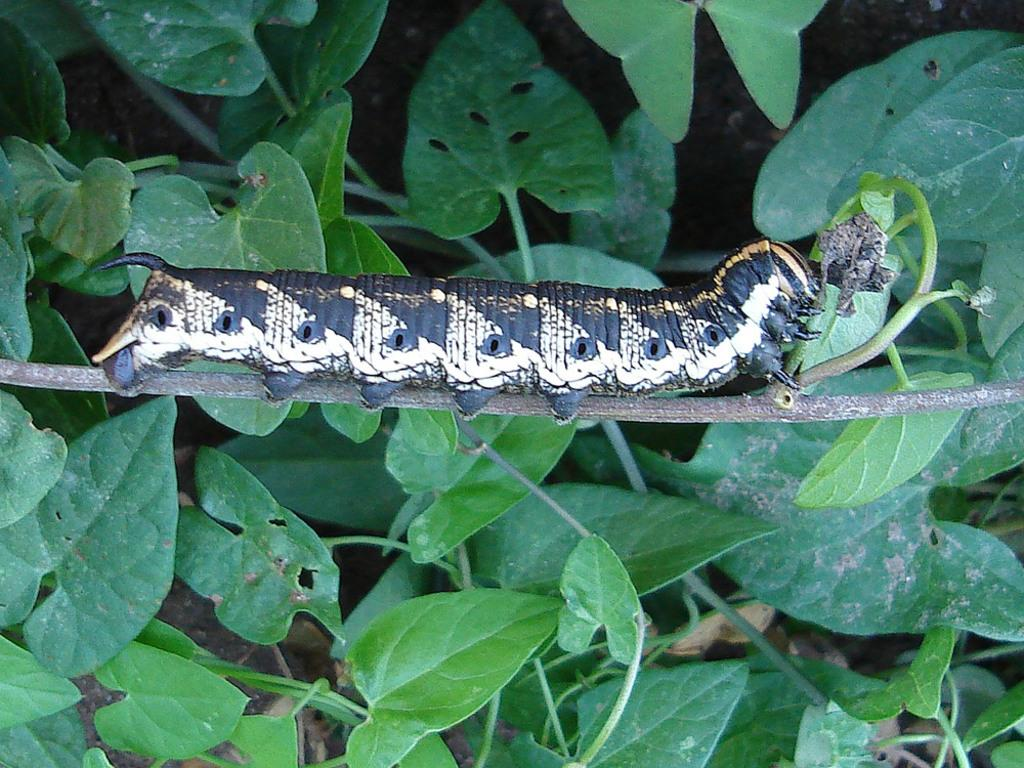What is on the branch in the image? There is an insect on a branch in the image. What type of vegetation is present in the image? There are green leaves in the image. What else can be seen in the image besides the insect and leaves? There are stems in the image. What is the opinion of the zephyr about the insect in the image? There is no zephyr present in the image, and therefore no opinion can be attributed to it. 